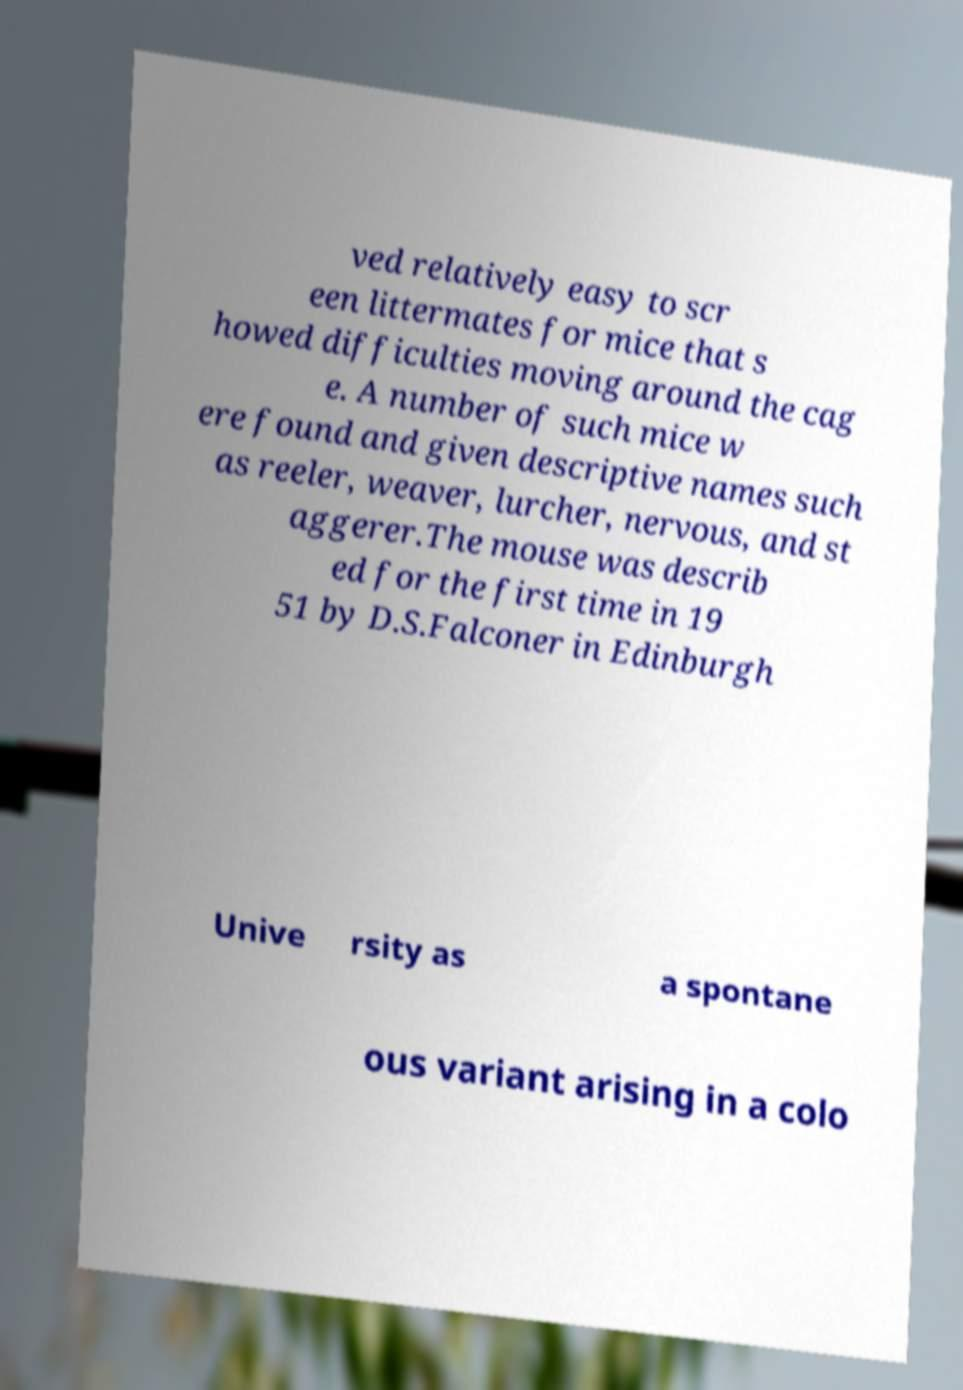Can you accurately transcribe the text from the provided image for me? ved relatively easy to scr een littermates for mice that s howed difficulties moving around the cag e. A number of such mice w ere found and given descriptive names such as reeler, weaver, lurcher, nervous, and st aggerer.The mouse was describ ed for the first time in 19 51 by D.S.Falconer in Edinburgh Unive rsity as a spontane ous variant arising in a colo 